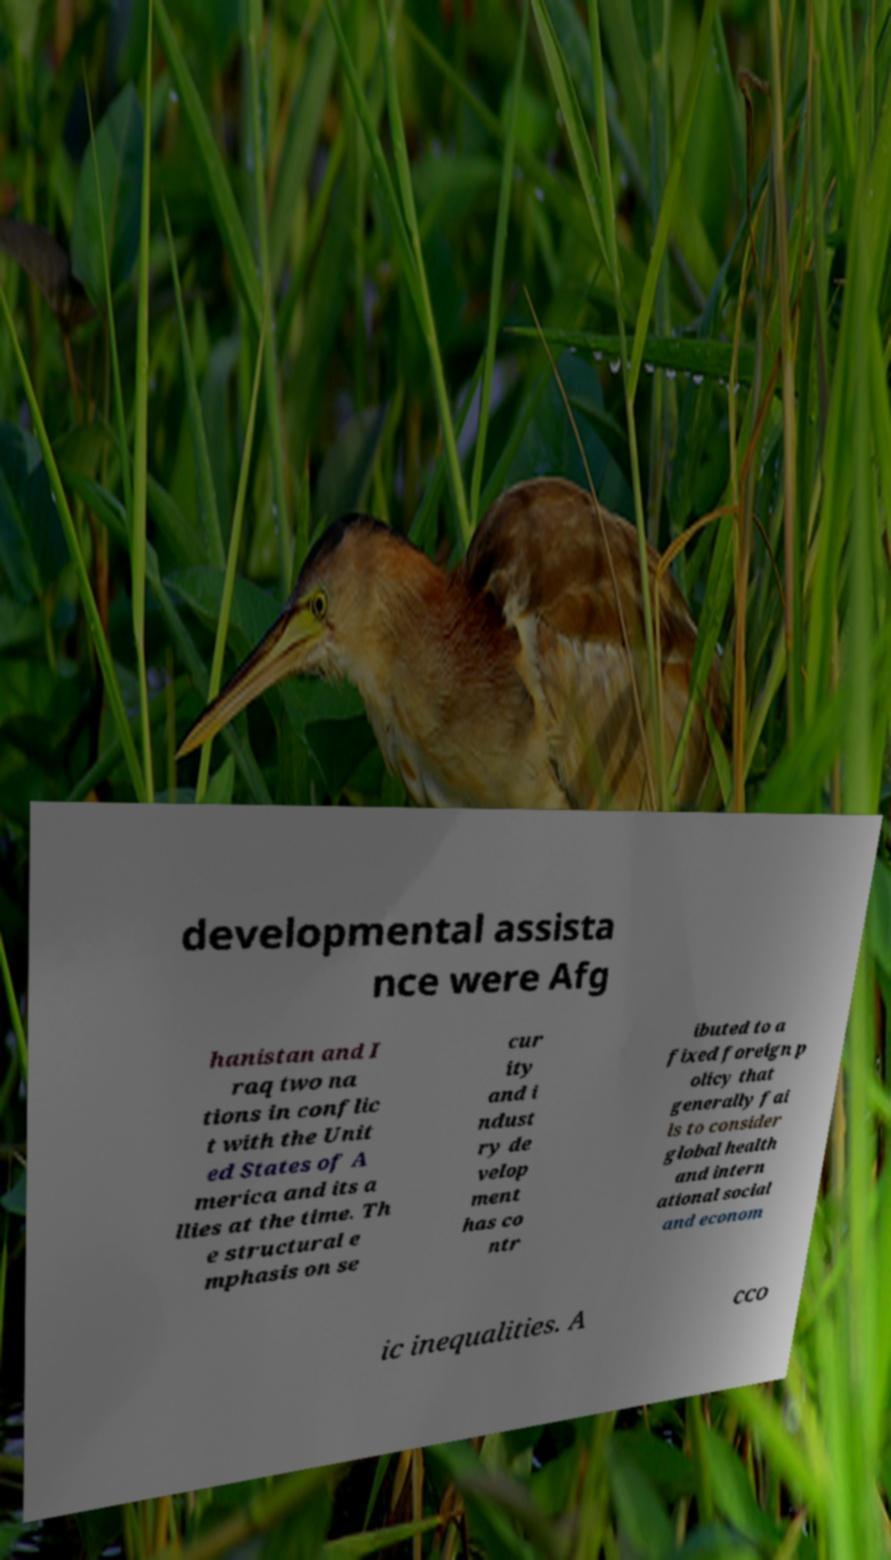Could you assist in decoding the text presented in this image and type it out clearly? developmental assista nce were Afg hanistan and I raq two na tions in conflic t with the Unit ed States of A merica and its a llies at the time. Th e structural e mphasis on se cur ity and i ndust ry de velop ment has co ntr ibuted to a fixed foreign p olicy that generally fai ls to consider global health and intern ational social and econom ic inequalities. A cco 